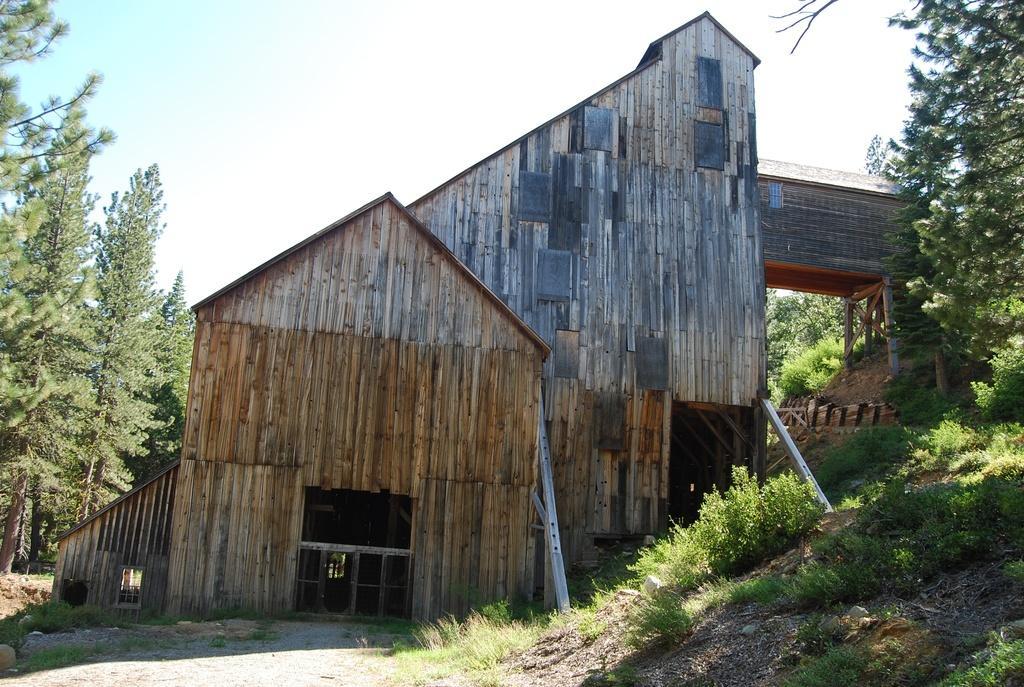Describe this image in one or two sentences. In the picture I can see a wooden building, the grass, trees and some other objects on the ground. In the background I can see the sky. 